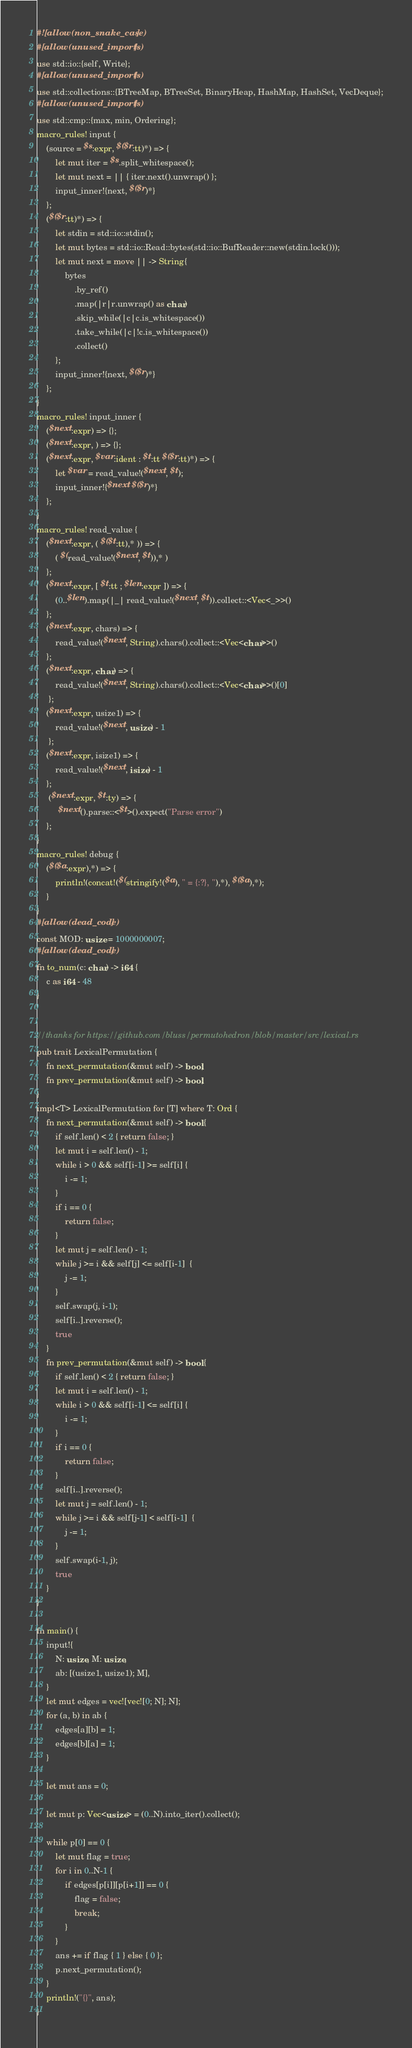Convert code to text. <code><loc_0><loc_0><loc_500><loc_500><_Rust_>#![allow(non_snake_case)]
#[allow(unused_imports)]
use std::io::{self, Write};
#[allow(unused_imports)]
use std::collections::{BTreeMap, BTreeSet, BinaryHeap, HashMap, HashSet, VecDeque};
#[allow(unused_imports)]
use std::cmp::{max, min, Ordering};
macro_rules! input {
    (source = $s:expr, $($r:tt)*) => {
        let mut iter = $s.split_whitespace();
        let mut next = || { iter.next().unwrap() };
        input_inner!{next, $($r)*}
    };
    ($($r:tt)*) => {
        let stdin = std::io::stdin();
        let mut bytes = std::io::Read::bytes(std::io::BufReader::new(stdin.lock()));
        let mut next = move || -> String{
            bytes
                .by_ref()
                .map(|r|r.unwrap() as char)
                .skip_while(|c|c.is_whitespace())
                .take_while(|c|!c.is_whitespace())
                .collect()
        };
        input_inner!{next, $($r)*}
    };
}
macro_rules! input_inner {
    ($next:expr) => {};
    ($next:expr, ) => {};
    ($next:expr, $var:ident : $t:tt $($r:tt)*) => {
        let $var = read_value!($next, $t);
        input_inner!{$next $($r)*}
    };
}
macro_rules! read_value {
    ($next:expr, ( $($t:tt),* )) => {
        ( $(read_value!($next, $t)),* )
    };
    ($next:expr, [ $t:tt ; $len:expr ]) => {
        (0..$len).map(|_| read_value!($next, $t)).collect::<Vec<_>>()
    };
    ($next:expr, chars) => {
        read_value!($next, String).chars().collect::<Vec<char>>()
    };
    ($next:expr, char) => {
        read_value!($next, String).chars().collect::<Vec<char>>()[0]
     };
    ($next:expr, usize1) => {
        read_value!($next, usize) - 1
     };
    ($next:expr, isize1) => {
        read_value!($next, isize) - 1
    };
     ($next:expr, $t:ty) => {
         $next().parse::<$t>().expect("Parse error")
    };
}
macro_rules! debug {
    ($($a:expr),*) => {
        println!(concat!($(stringify!($a), " = {:?}, "),*), $($a),*);
    }
}
#[allow(dead_code)]
const MOD: usize = 1000000007;
#[allow(dead_code)]
fn to_num(c: char) -> i64 {
    c as i64 - 48
}


//thanks for https://github.com/bluss/permutohedron/blob/master/src/lexical.rs
pub trait LexicalPermutation {
    fn next_permutation(&mut self) -> bool;
    fn prev_permutation(&mut self) -> bool;
}
impl<T> LexicalPermutation for [T] where T: Ord {
    fn next_permutation(&mut self) -> bool {
        if self.len() < 2 { return false; }
        let mut i = self.len() - 1;
        while i > 0 && self[i-1] >= self[i] {
            i -= 1;
        }
        if i == 0 {
            return false;
        }
        let mut j = self.len() - 1;
        while j >= i && self[j] <= self[i-1]  {
            j -= 1;
        }
        self.swap(j, i-1);
        self[i..].reverse();
        true
    }
    fn prev_permutation(&mut self) -> bool {
        if self.len() < 2 { return false; }
        let mut i = self.len() - 1;
        while i > 0 && self[i-1] <= self[i] {
            i -= 1;
        }
        if i == 0 {
            return false;
        }
        self[i..].reverse();
        let mut j = self.len() - 1;
        while j >= i && self[j-1] < self[i-1]  {
            j -= 1;
        }
        self.swap(i-1, j);
        true
    }
}

fn main() {
    input!{
        N: usize, M: usize,
        ab: [(usize1, usize1); M],
    }
    let mut edges = vec![vec![0; N]; N];
    for (a, b) in ab {
        edges[a][b] = 1;
        edges[b][a] = 1;
    }

    let mut ans = 0;

    let mut p: Vec<usize> = (0..N).into_iter().collect();

    while p[0] == 0 {
        let mut flag = true;
        for i in 0..N-1 {
            if edges[p[i]][p[i+1]] == 0 {
                flag = false;
                break;
            }
        }
        ans += if flag { 1 } else { 0 };
        p.next_permutation();
    }
    println!("{}", ans);
}</code> 